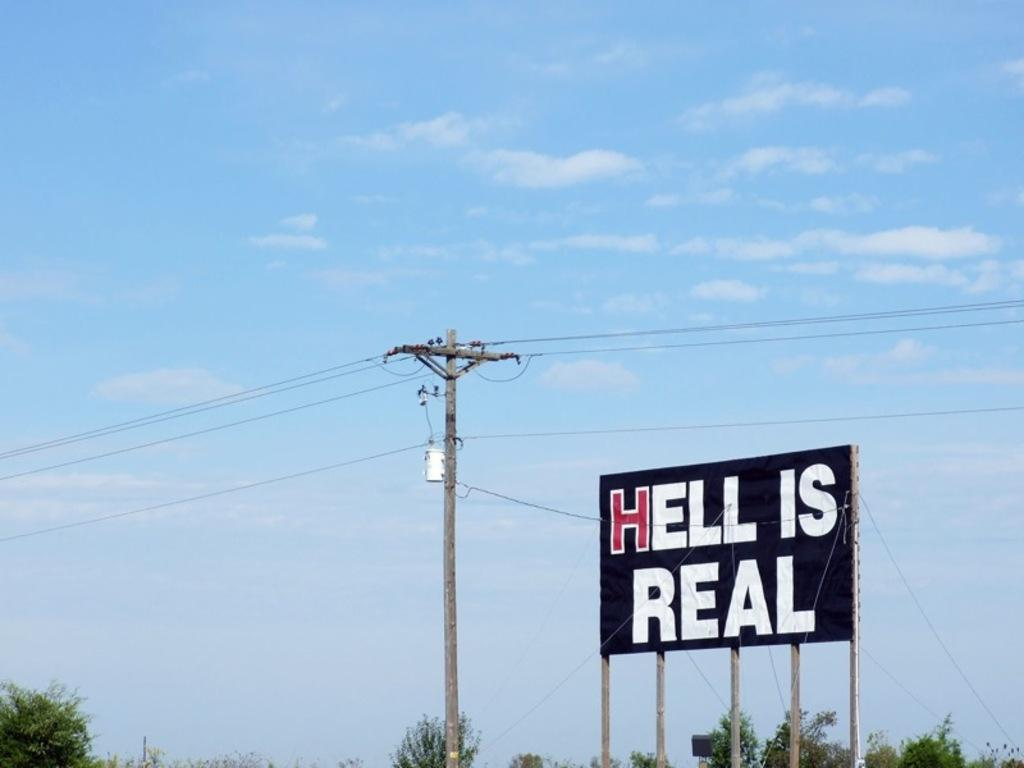<image>
Summarize the visual content of the image. A large public sign that says HELL IS REAL. 